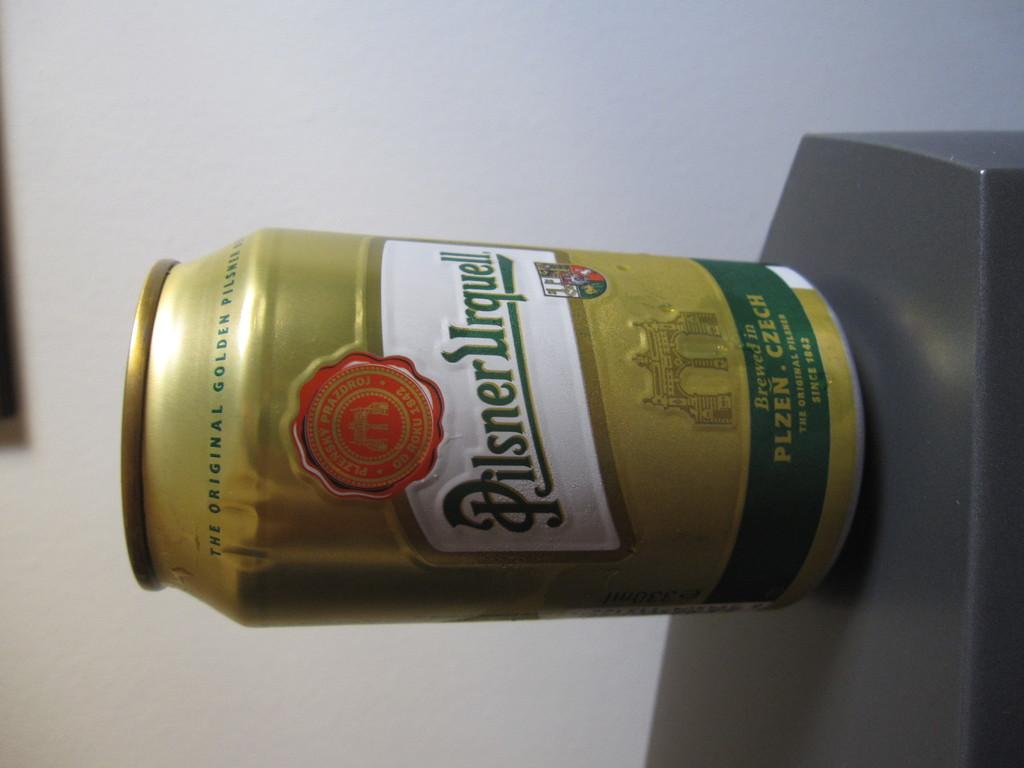<image>
Provide a brief description of the given image. A yellow and green can of Pilsner that is sideways on a surface. 